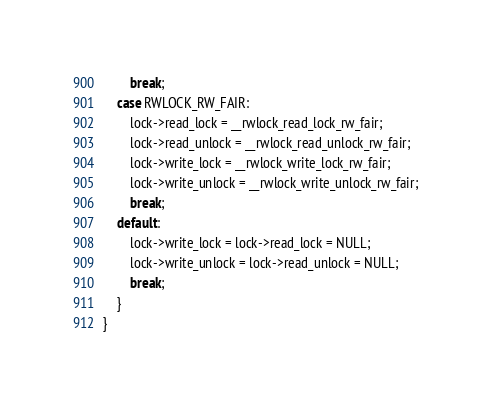Convert code to text. <code><loc_0><loc_0><loc_500><loc_500><_C_>        break;
    case RWLOCK_RW_FAIR:
        lock->read_lock = __rwlock_read_lock_rw_fair;
        lock->read_unlock = __rwlock_read_unlock_rw_fair;
        lock->write_lock = __rwlock_write_lock_rw_fair;
        lock->write_unlock = __rwlock_write_unlock_rw_fair;
        break;
    default:
        lock->write_lock = lock->read_lock = NULL;
        lock->write_unlock = lock->read_unlock = NULL;
        break;
    }
} 
</code> 